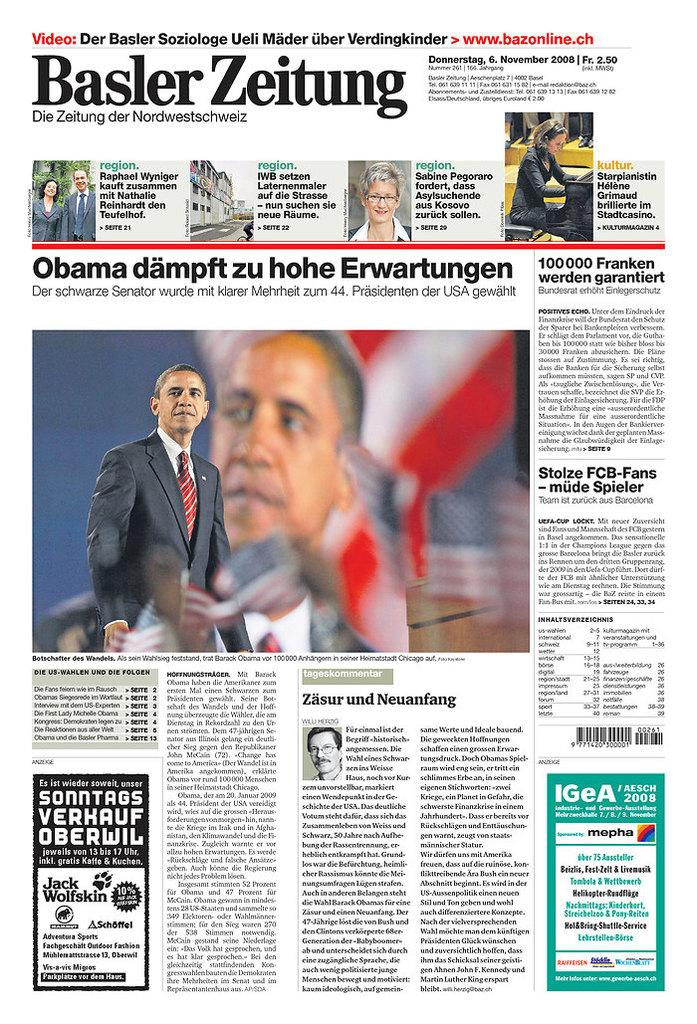What is the main subject of the image? The main subject of the image is a newspaper. Can you describe any people present in the image? Yes, there are persons in the image. What type of content can be found in the image? There is text in the image. What type of observation can be made about the army in the image? There is no mention of an army or any observation related to an army in the image. 